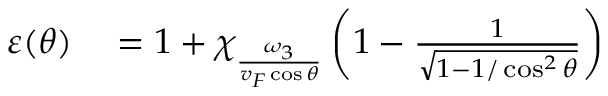Convert formula to latex. <formula><loc_0><loc_0><loc_500><loc_500>\begin{array} { r l } { \varepsilon ( \theta ) } & = 1 + \chi _ { \frac { \omega _ { 3 } } { v _ { F } \cos \theta } } \left ( 1 - \frac { 1 } { \sqrt { 1 - 1 / \cos ^ { 2 } \theta } } \right ) } \end{array}</formula> 